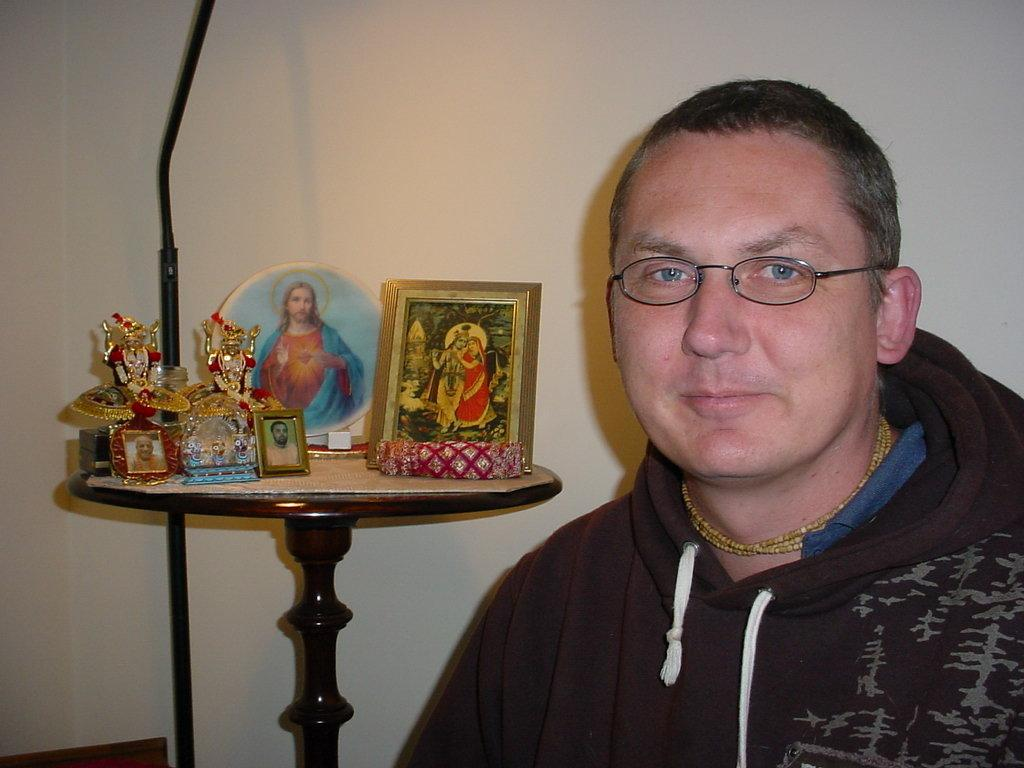Who is present in the image? There is a man in the image. What can be observed about the man's appearance? The man is wearing glasses and smiling. What is visible on the table in the background? There are idols and frames on a table in the background. What is the background of the image like? There is a plain wall in the background. Can you see any nests in the image? There are no nests present in the image. How many cars are parked near the man in the image? There are no cars visible in the image. 